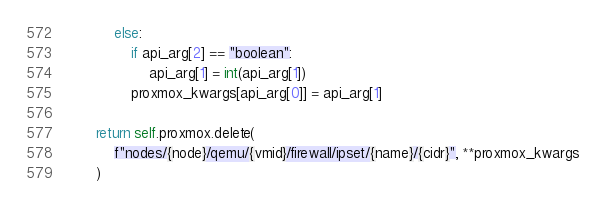Convert code to text. <code><loc_0><loc_0><loc_500><loc_500><_Python_>            else:
                if api_arg[2] == "boolean":
                    api_arg[1] = int(api_arg[1])
                proxmox_kwargs[api_arg[0]] = api_arg[1]

        return self.proxmox.delete(
            f"nodes/{node}/qemu/{vmid}/firewall/ipset/{name}/{cidr}", **proxmox_kwargs
        )
</code> 